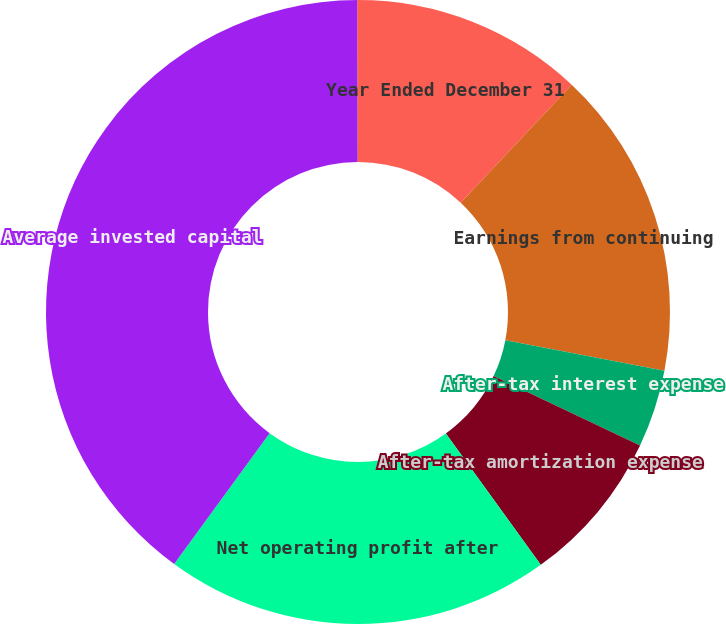Convert chart. <chart><loc_0><loc_0><loc_500><loc_500><pie_chart><fcel>Year Ended December 31<fcel>Earnings from continuing<fcel>After-tax interest expense<fcel>After-tax amortization expense<fcel>Net operating profit after<fcel>Average invested capital<fcel>Return on invested capital<nl><fcel>12.01%<fcel>16.0%<fcel>4.02%<fcel>8.01%<fcel>19.99%<fcel>39.94%<fcel>0.03%<nl></chart> 